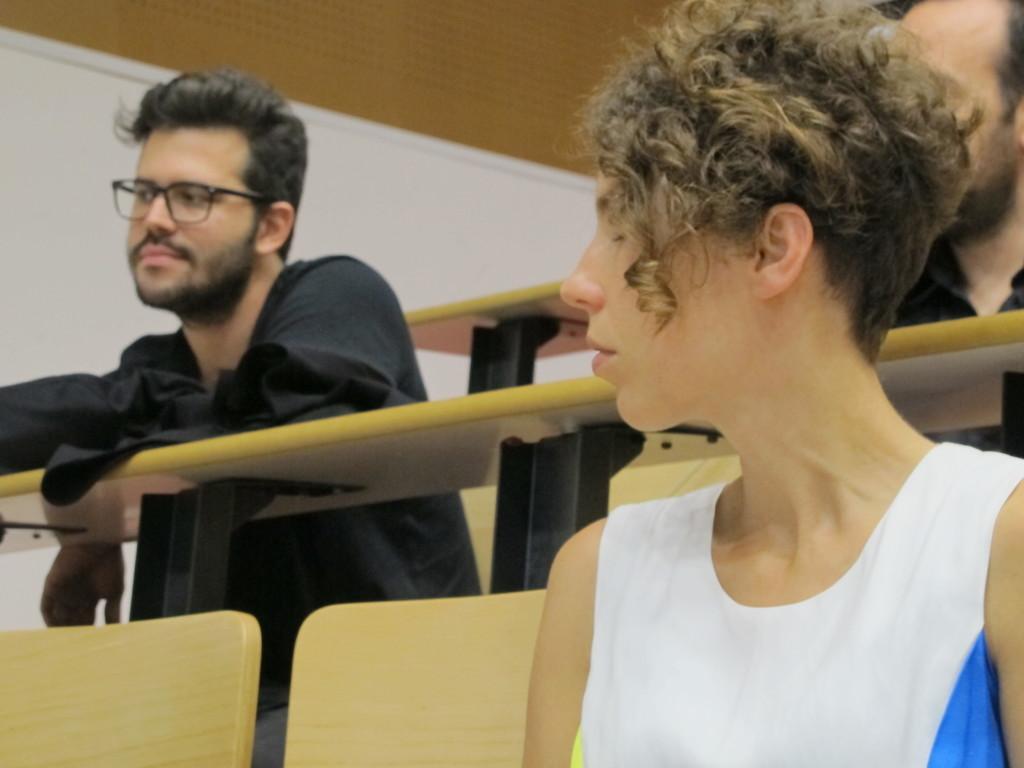In one or two sentences, can you explain what this image depicts? In this foreground of the image we can see one woman is sitting on a wooden chair. She is wearing a white color top. Behind her, two men are sitting and we can see tables. At the top of the image, there is a wall. 